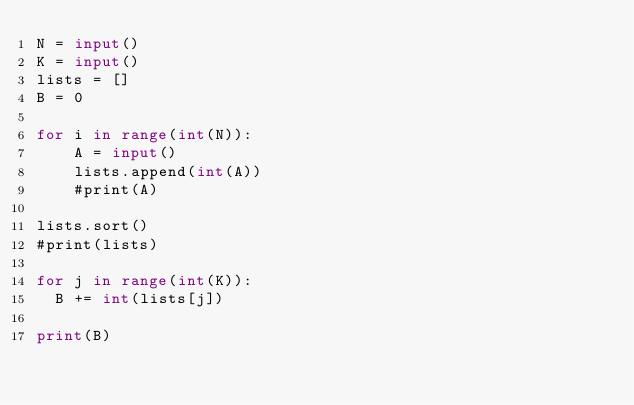<code> <loc_0><loc_0><loc_500><loc_500><_Python_>N = input()
K = input()
lists = []
B = 0

for i in range(int(N)):
    A = input()
    lists.append(int(A))
    #print(A)

lists.sort()
#print(lists)

for j in range(int(K)):
  B += int(lists[j])
 
print(B)</code> 